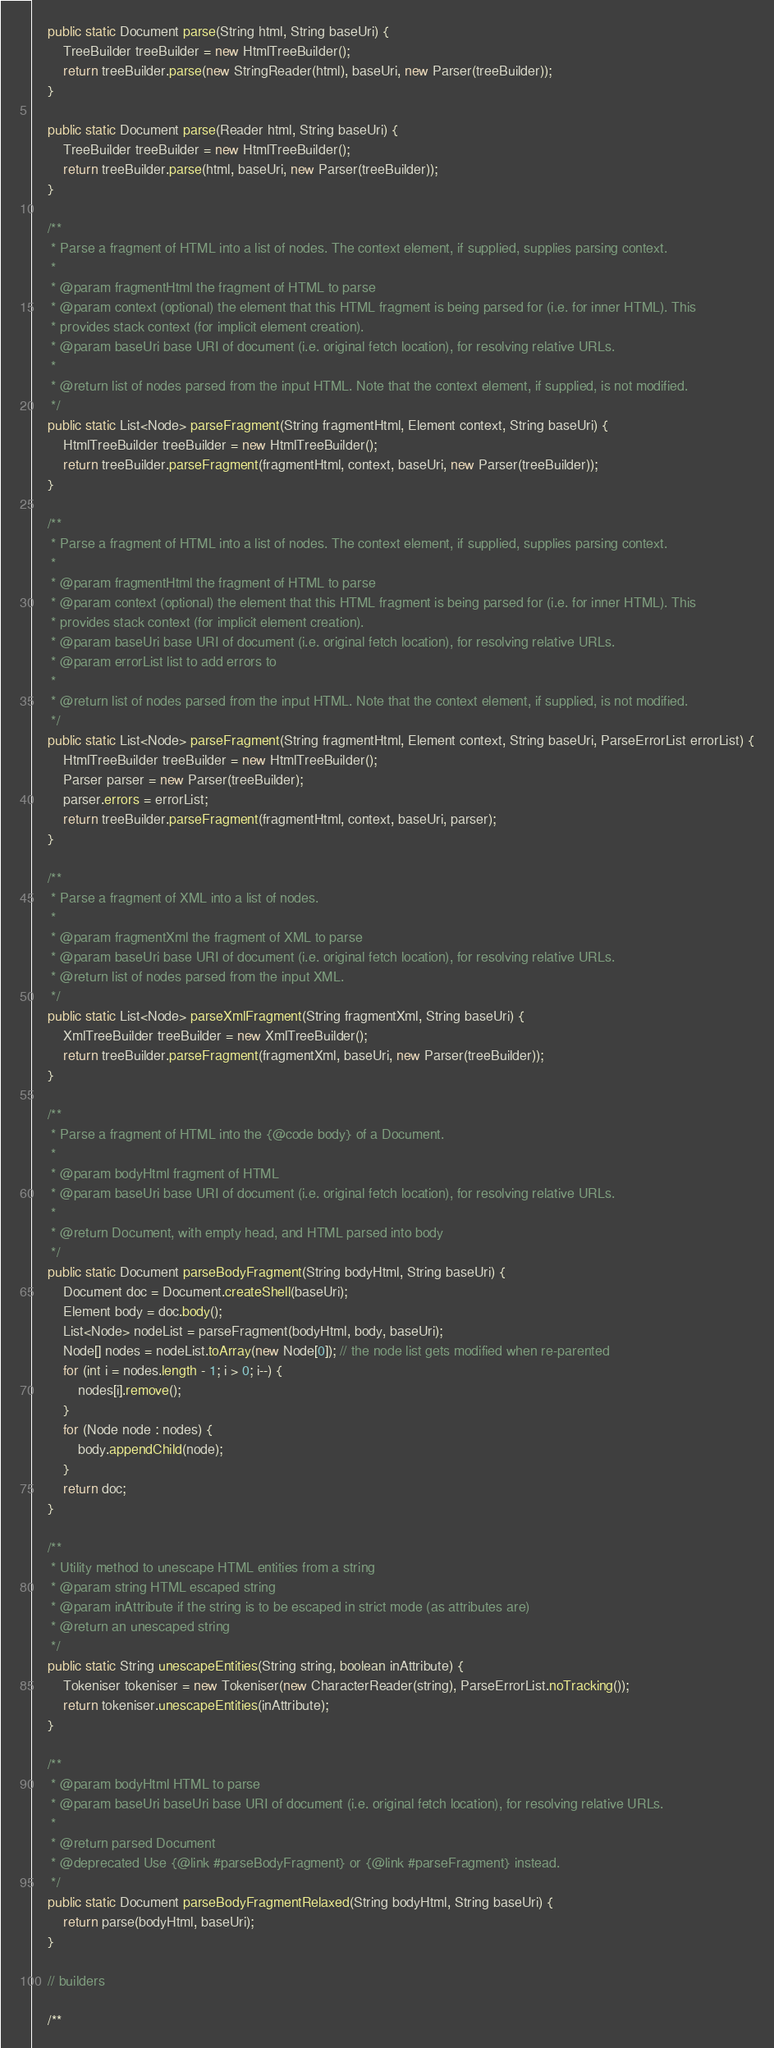<code> <loc_0><loc_0><loc_500><loc_500><_Java_>    public static Document parse(String html, String baseUri) {
        TreeBuilder treeBuilder = new HtmlTreeBuilder();
        return treeBuilder.parse(new StringReader(html), baseUri, new Parser(treeBuilder));
    }

    public static Document parse(Reader html, String baseUri) {
        TreeBuilder treeBuilder = new HtmlTreeBuilder();
        return treeBuilder.parse(html, baseUri, new Parser(treeBuilder));
    }

    /**
     * Parse a fragment of HTML into a list of nodes. The context element, if supplied, supplies parsing context.
     *
     * @param fragmentHtml the fragment of HTML to parse
     * @param context (optional) the element that this HTML fragment is being parsed for (i.e. for inner HTML). This
     * provides stack context (for implicit element creation).
     * @param baseUri base URI of document (i.e. original fetch location), for resolving relative URLs.
     *
     * @return list of nodes parsed from the input HTML. Note that the context element, if supplied, is not modified.
     */
    public static List<Node> parseFragment(String fragmentHtml, Element context, String baseUri) {
        HtmlTreeBuilder treeBuilder = new HtmlTreeBuilder();
        return treeBuilder.parseFragment(fragmentHtml, context, baseUri, new Parser(treeBuilder));
    }

    /**
     * Parse a fragment of HTML into a list of nodes. The context element, if supplied, supplies parsing context.
     *
     * @param fragmentHtml the fragment of HTML to parse
     * @param context (optional) the element that this HTML fragment is being parsed for (i.e. for inner HTML). This
     * provides stack context (for implicit element creation).
     * @param baseUri base URI of document (i.e. original fetch location), for resolving relative URLs.
     * @param errorList list to add errors to
     *
     * @return list of nodes parsed from the input HTML. Note that the context element, if supplied, is not modified.
     */
    public static List<Node> parseFragment(String fragmentHtml, Element context, String baseUri, ParseErrorList errorList) {
        HtmlTreeBuilder treeBuilder = new HtmlTreeBuilder();
        Parser parser = new Parser(treeBuilder);
        parser.errors = errorList;
        return treeBuilder.parseFragment(fragmentHtml, context, baseUri, parser);
    }

    /**
     * Parse a fragment of XML into a list of nodes.
     *
     * @param fragmentXml the fragment of XML to parse
     * @param baseUri base URI of document (i.e. original fetch location), for resolving relative URLs.
     * @return list of nodes parsed from the input XML.
     */
    public static List<Node> parseXmlFragment(String fragmentXml, String baseUri) {
        XmlTreeBuilder treeBuilder = new XmlTreeBuilder();
        return treeBuilder.parseFragment(fragmentXml, baseUri, new Parser(treeBuilder));
    }

    /**
     * Parse a fragment of HTML into the {@code body} of a Document.
     *
     * @param bodyHtml fragment of HTML
     * @param baseUri base URI of document (i.e. original fetch location), for resolving relative URLs.
     *
     * @return Document, with empty head, and HTML parsed into body
     */
    public static Document parseBodyFragment(String bodyHtml, String baseUri) {
        Document doc = Document.createShell(baseUri);
        Element body = doc.body();
        List<Node> nodeList = parseFragment(bodyHtml, body, baseUri);
        Node[] nodes = nodeList.toArray(new Node[0]); // the node list gets modified when re-parented
        for (int i = nodes.length - 1; i > 0; i--) {
            nodes[i].remove();
        }
        for (Node node : nodes) {
            body.appendChild(node);
        }
        return doc;
    }

    /**
     * Utility method to unescape HTML entities from a string
     * @param string HTML escaped string
     * @param inAttribute if the string is to be escaped in strict mode (as attributes are)
     * @return an unescaped string
     */
    public static String unescapeEntities(String string, boolean inAttribute) {
        Tokeniser tokeniser = new Tokeniser(new CharacterReader(string), ParseErrorList.noTracking());
        return tokeniser.unescapeEntities(inAttribute);
    }

    /**
     * @param bodyHtml HTML to parse
     * @param baseUri baseUri base URI of document (i.e. original fetch location), for resolving relative URLs.
     *
     * @return parsed Document
     * @deprecated Use {@link #parseBodyFragment} or {@link #parseFragment} instead.
     */
    public static Document parseBodyFragmentRelaxed(String bodyHtml, String baseUri) {
        return parse(bodyHtml, baseUri);
    }
    
    // builders

    /**</code> 